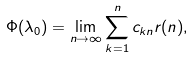<formula> <loc_0><loc_0><loc_500><loc_500>\Phi ( \lambda _ { 0 } ) = \lim _ { n \rightarrow \infty } \sum _ { k = 1 } ^ { n } c _ { k n } r ( n ) ,</formula> 